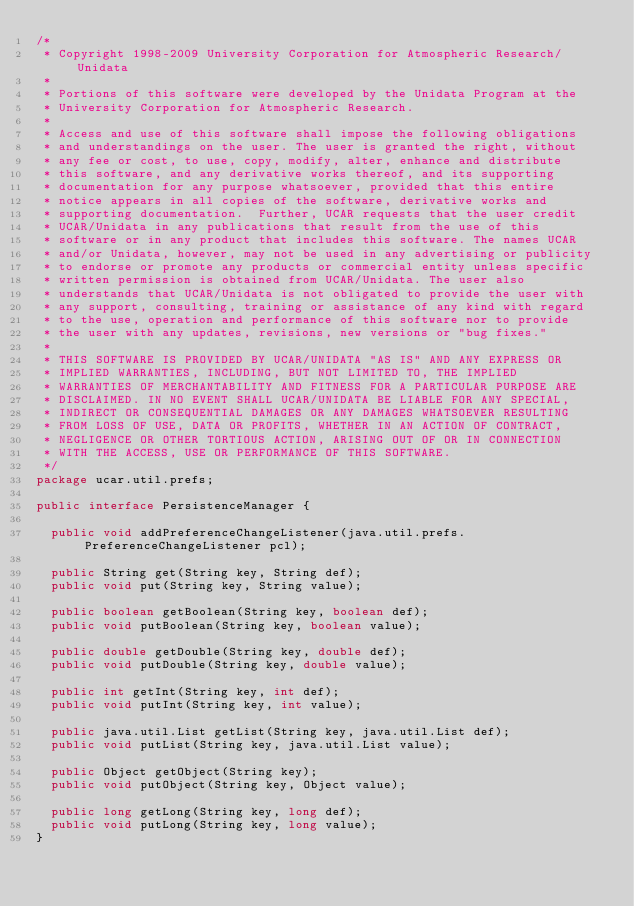<code> <loc_0><loc_0><loc_500><loc_500><_Java_>/*
 * Copyright 1998-2009 University Corporation for Atmospheric Research/Unidata
 *
 * Portions of this software were developed by the Unidata Program at the
 * University Corporation for Atmospheric Research.
 *
 * Access and use of this software shall impose the following obligations
 * and understandings on the user. The user is granted the right, without
 * any fee or cost, to use, copy, modify, alter, enhance and distribute
 * this software, and any derivative works thereof, and its supporting
 * documentation for any purpose whatsoever, provided that this entire
 * notice appears in all copies of the software, derivative works and
 * supporting documentation.  Further, UCAR requests that the user credit
 * UCAR/Unidata in any publications that result from the use of this
 * software or in any product that includes this software. The names UCAR
 * and/or Unidata, however, may not be used in any advertising or publicity
 * to endorse or promote any products or commercial entity unless specific
 * written permission is obtained from UCAR/Unidata. The user also
 * understands that UCAR/Unidata is not obligated to provide the user with
 * any support, consulting, training or assistance of any kind with regard
 * to the use, operation and performance of this software nor to provide
 * the user with any updates, revisions, new versions or "bug fixes."
 *
 * THIS SOFTWARE IS PROVIDED BY UCAR/UNIDATA "AS IS" AND ANY EXPRESS OR
 * IMPLIED WARRANTIES, INCLUDING, BUT NOT LIMITED TO, THE IMPLIED
 * WARRANTIES OF MERCHANTABILITY AND FITNESS FOR A PARTICULAR PURPOSE ARE
 * DISCLAIMED. IN NO EVENT SHALL UCAR/UNIDATA BE LIABLE FOR ANY SPECIAL,
 * INDIRECT OR CONSEQUENTIAL DAMAGES OR ANY DAMAGES WHATSOEVER RESULTING
 * FROM LOSS OF USE, DATA OR PROFITS, WHETHER IN AN ACTION OF CONTRACT,
 * NEGLIGENCE OR OTHER TORTIOUS ACTION, ARISING OUT OF OR IN CONNECTION
 * WITH THE ACCESS, USE OR PERFORMANCE OF THIS SOFTWARE.
 */
package ucar.util.prefs;

public interface PersistenceManager {

  public void addPreferenceChangeListener(java.util.prefs.PreferenceChangeListener pcl);

  public String get(String key, String def);
  public void put(String key, String value);

  public boolean getBoolean(String key, boolean def);
  public void putBoolean(String key, boolean value);

  public double getDouble(String key, double def);
  public void putDouble(String key, double value);

  public int getInt(String key, int def);
  public void putInt(String key, int value);

  public java.util.List getList(String key, java.util.List def);
  public void putList(String key, java.util.List value);

  public Object getObject(String key);
  public void putObject(String key, Object value);

  public long getLong(String key, long def);
  public void putLong(String key, long value);
}</code> 